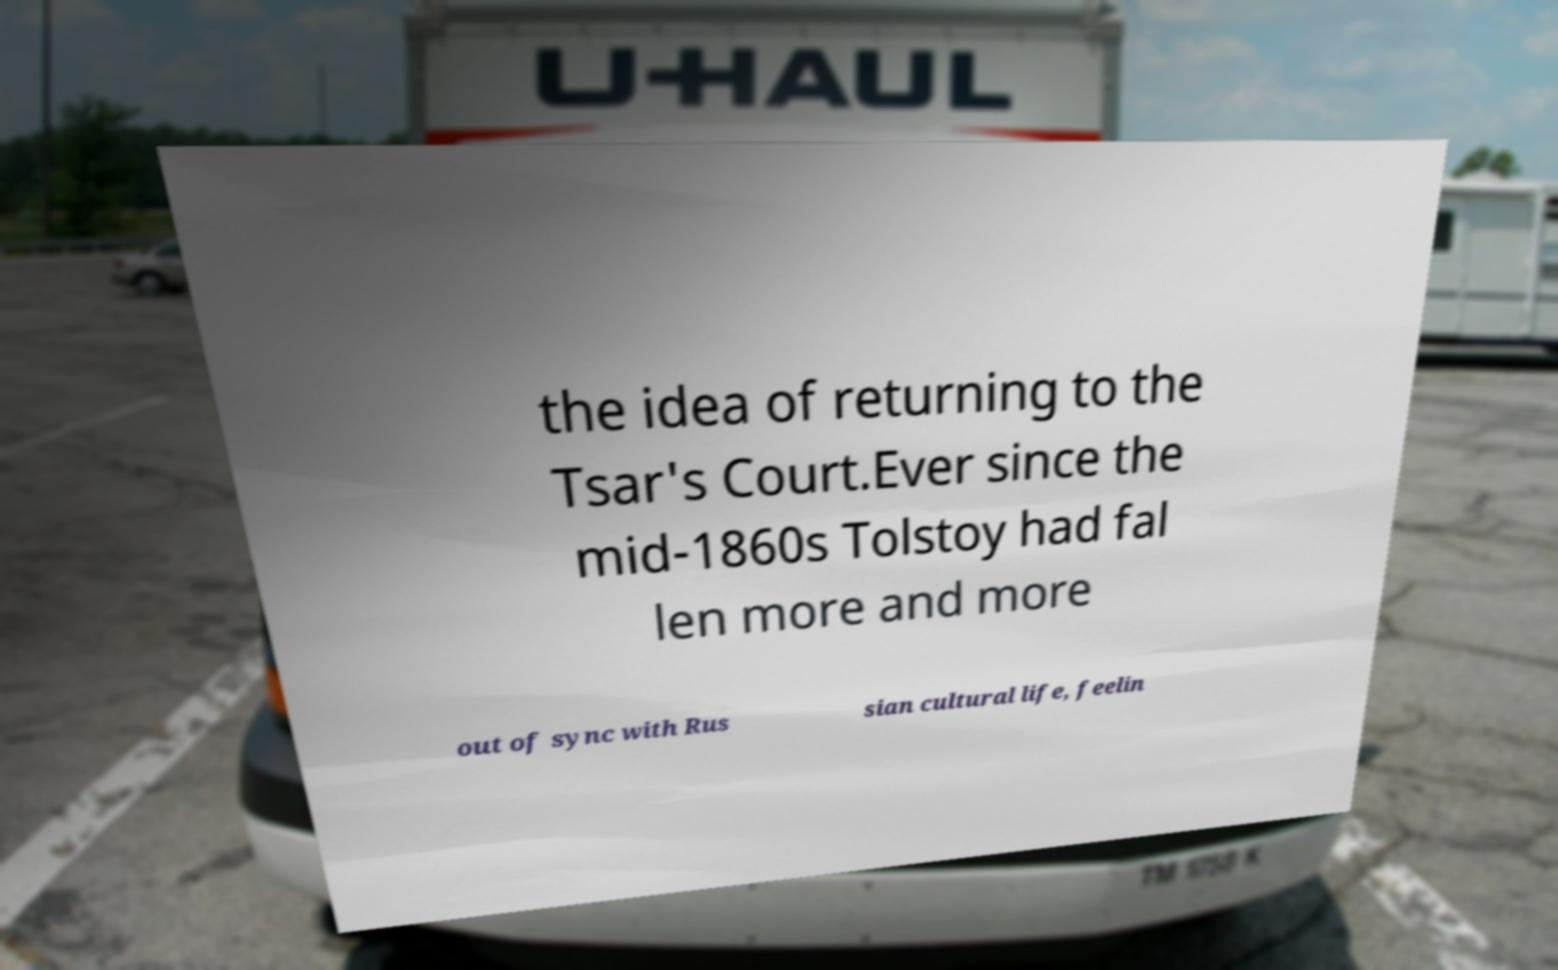I need the written content from this picture converted into text. Can you do that? the idea of returning to the Tsar's Court.Ever since the mid-1860s Tolstoy had fal len more and more out of sync with Rus sian cultural life, feelin 